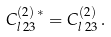<formula> <loc_0><loc_0><loc_500><loc_500>C ^ { ( 2 ) \, \ast } _ { l \, 2 3 } = C ^ { ( 2 ) } _ { l \, 2 3 } \, .</formula> 